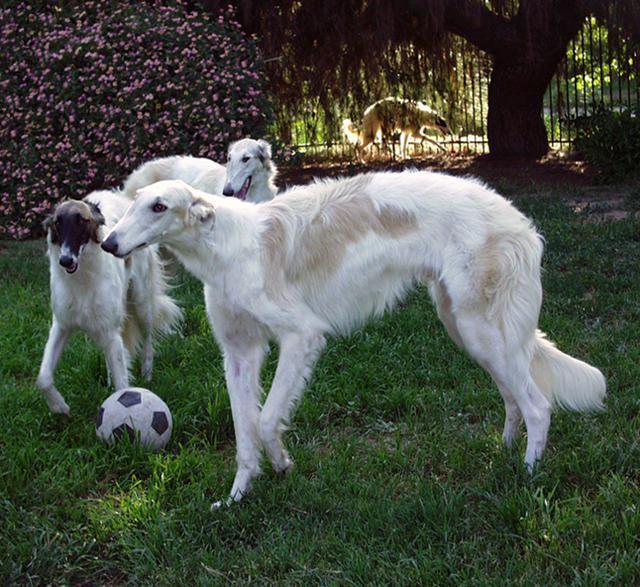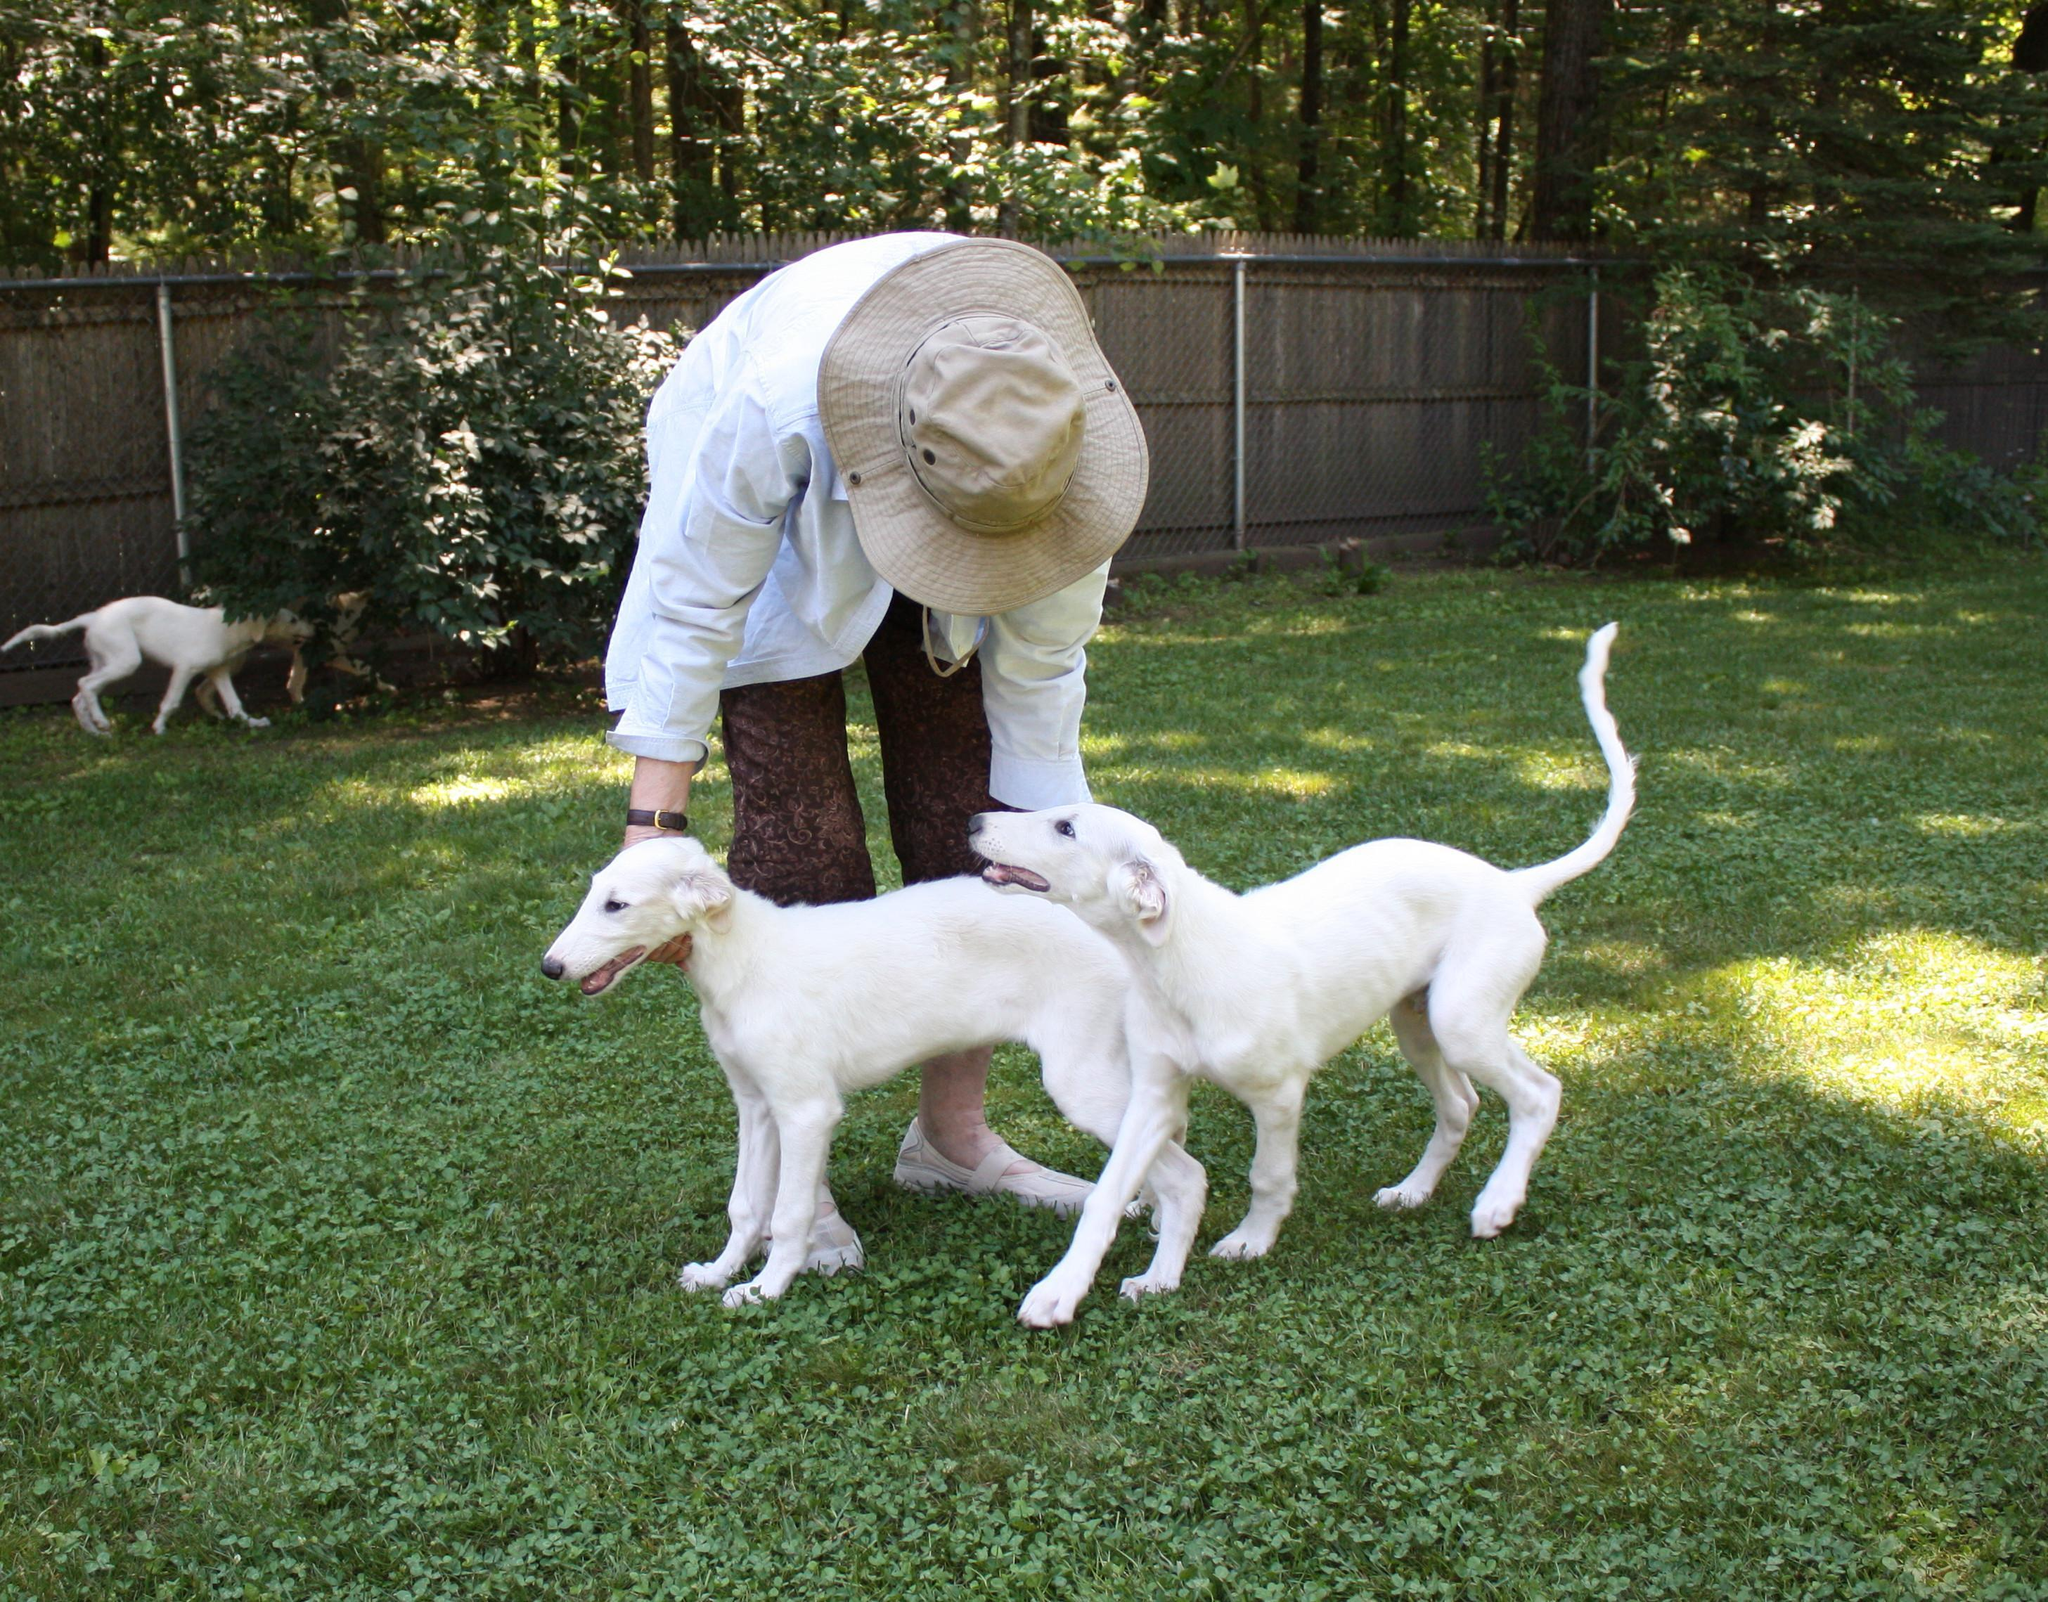The first image is the image on the left, the second image is the image on the right. Considering the images on both sides, is "A dog is being touched by a human in one of the images." valid? Answer yes or no. Yes. 